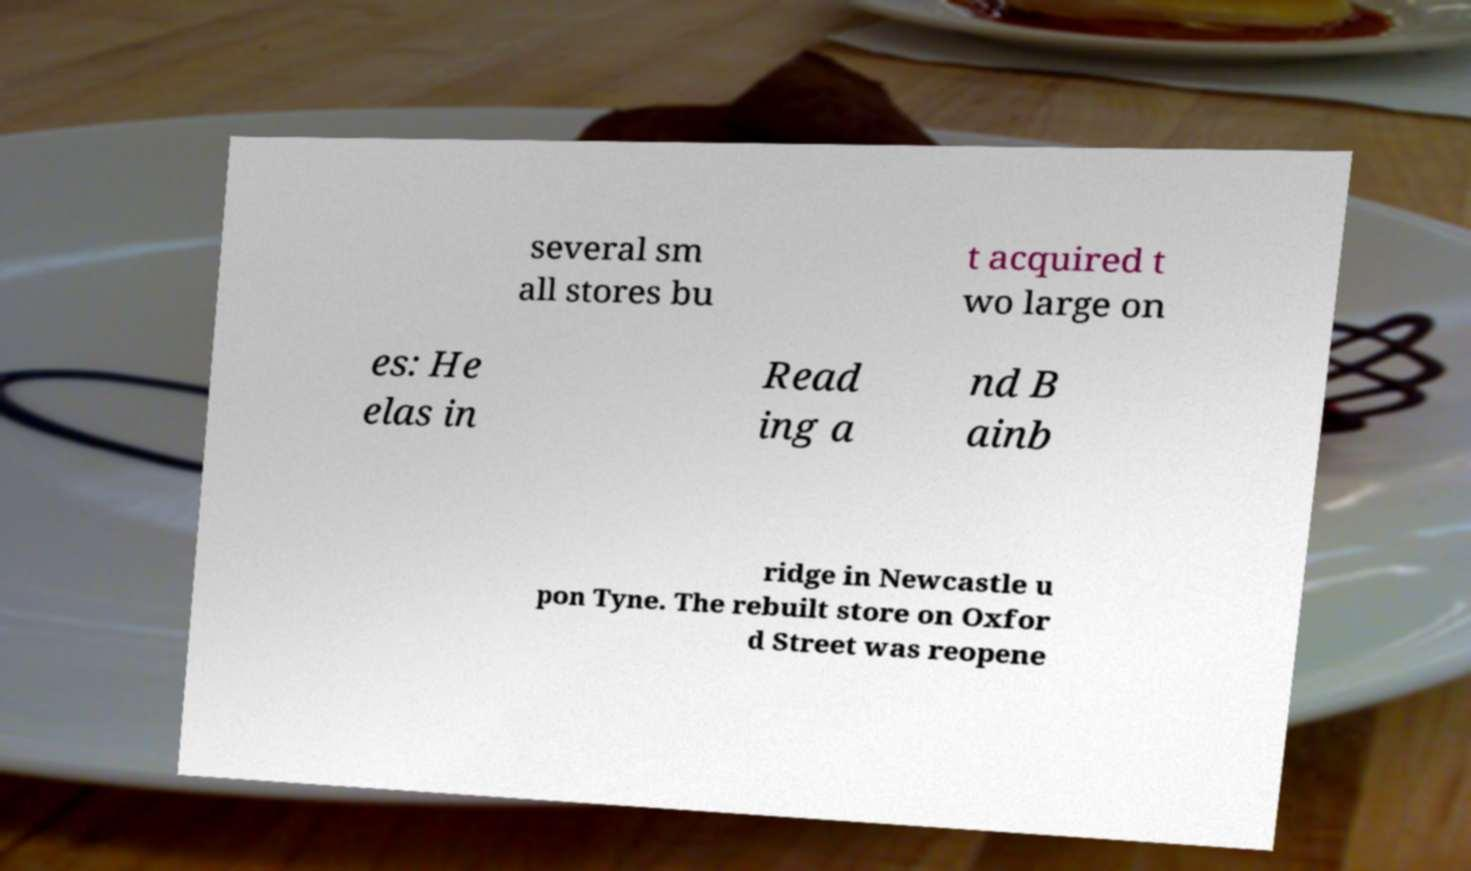Please identify and transcribe the text found in this image. several sm all stores bu t acquired t wo large on es: He elas in Read ing a nd B ainb ridge in Newcastle u pon Tyne. The rebuilt store on Oxfor d Street was reopene 